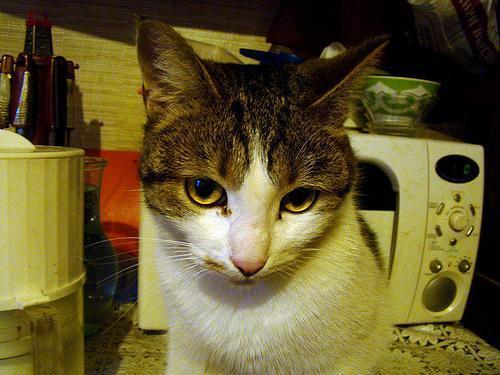How many cats are in the photo?
Give a very brief answer. 1. 